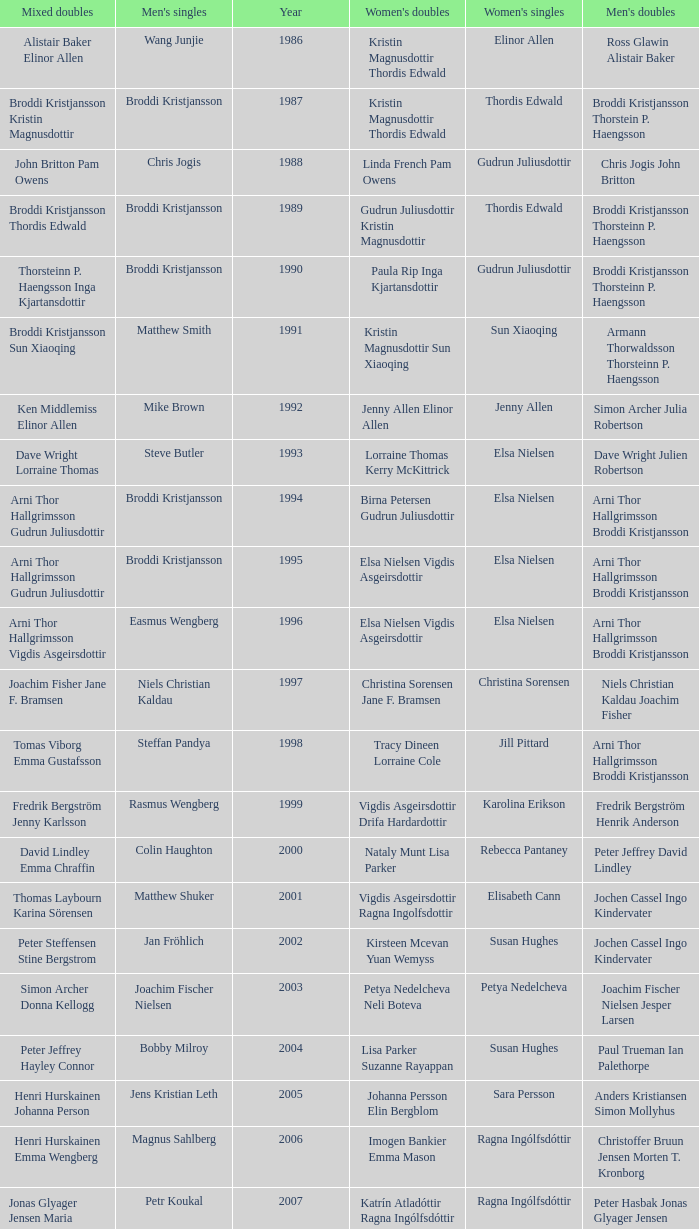In which women's doubles did Wang Junjie play men's singles? Kristin Magnusdottir Thordis Edwald. 